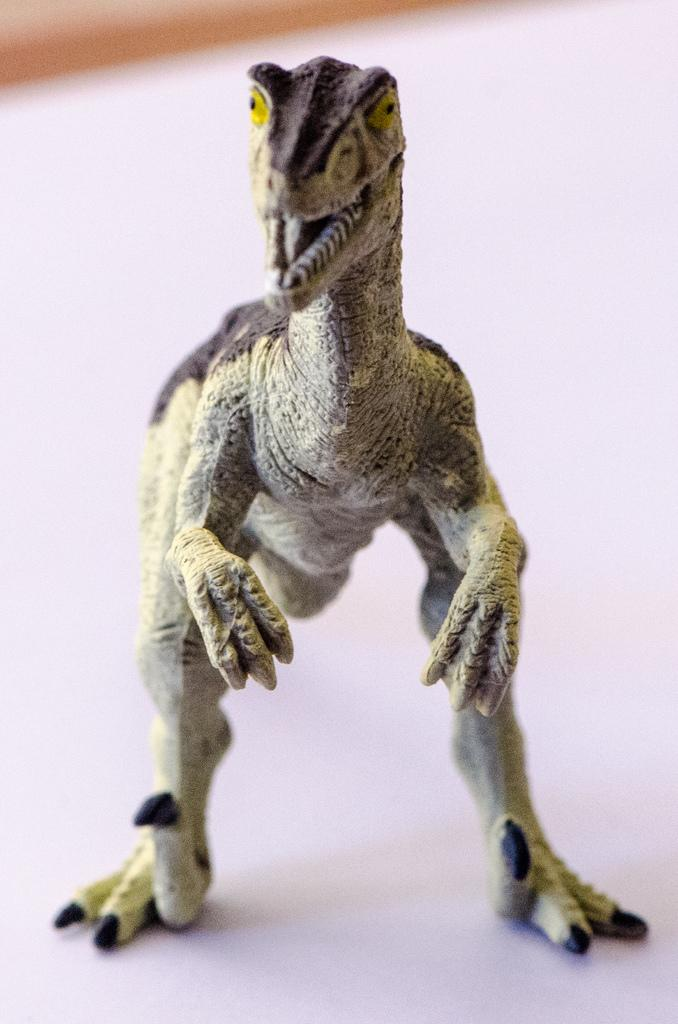What type of toy is present in the image? There is a dragon toy in the image. Can you describe the toy in more detail? The toy is a dragon, which is a mythical creature often depicted with wings, sharp claws, and fire-breathing abilities. What might the dragon toy be used for? The dragon toy could be used for play or as a decorative item. What type of soup is being produced by the dragon toy in the image? There is no soup or production process depicted in the image; it only features a dragon toy. 